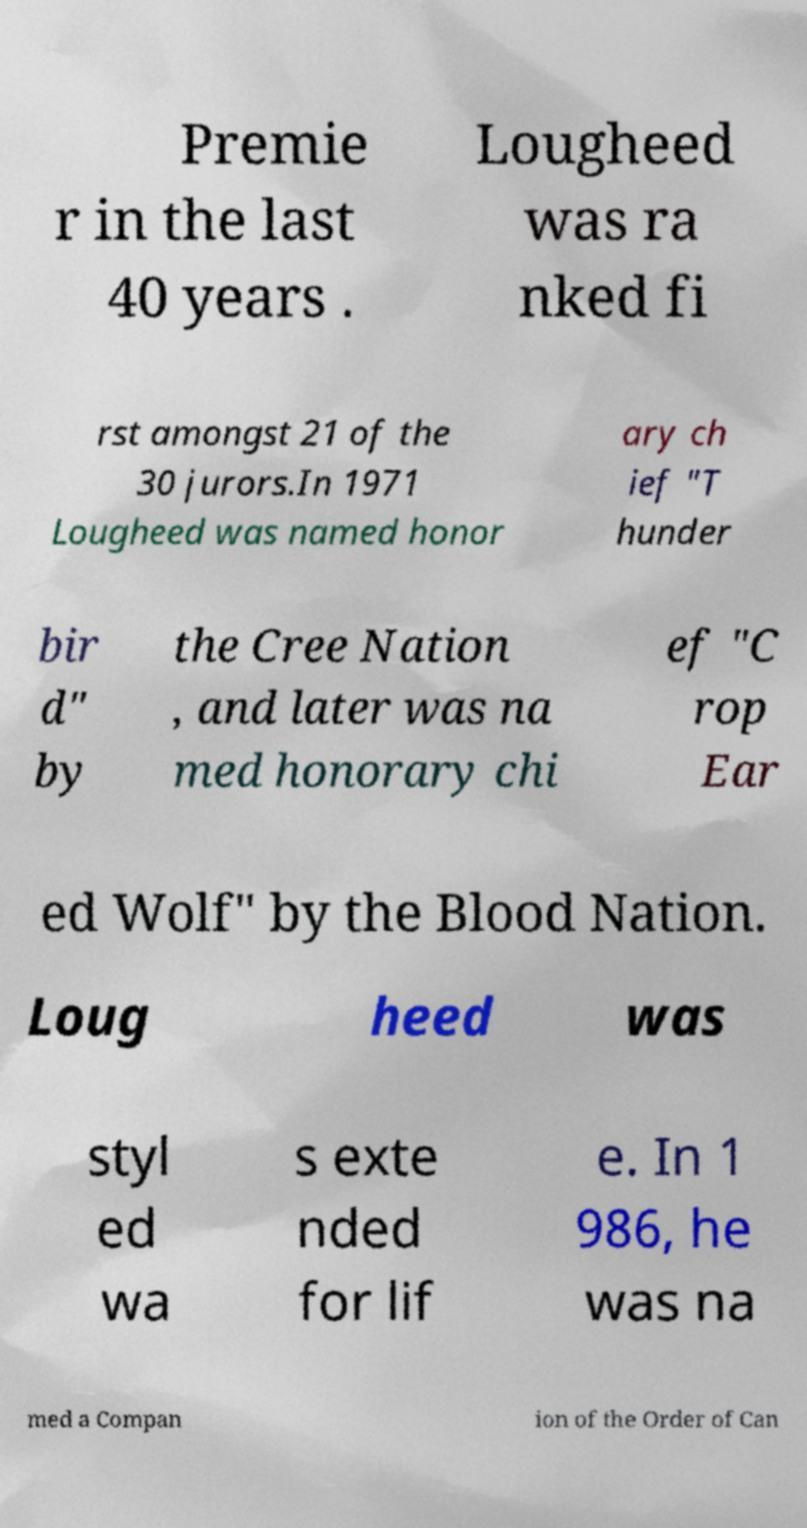Please read and relay the text visible in this image. What does it say? Premie r in the last 40 years . Lougheed was ra nked fi rst amongst 21 of the 30 jurors.In 1971 Lougheed was named honor ary ch ief "T hunder bir d" by the Cree Nation , and later was na med honorary chi ef "C rop Ear ed Wolf" by the Blood Nation. Loug heed was styl ed wa s exte nded for lif e. In 1 986, he was na med a Compan ion of the Order of Can 